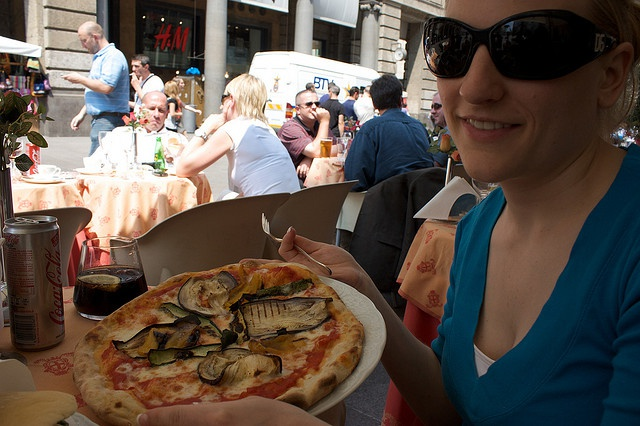Describe the objects in this image and their specific colors. I can see people in black, maroon, brown, and darkblue tones, pizza in black, maroon, and gray tones, dining table in black, ivory, tan, and salmon tones, chair in black, maroon, and gray tones, and people in black, white, darkgray, lavender, and tan tones in this image. 